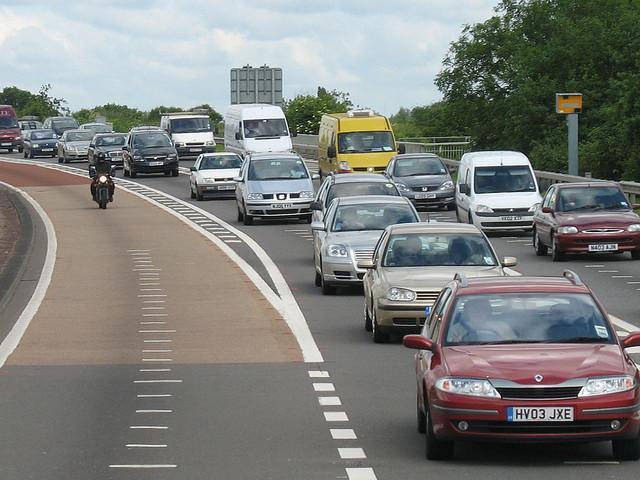How many motorcycles do you see?
Give a very brief answer. 1. How many cars are there?
Give a very brief answer. 8. How many trucks are there?
Give a very brief answer. 4. How many red chairs here?
Give a very brief answer. 0. 